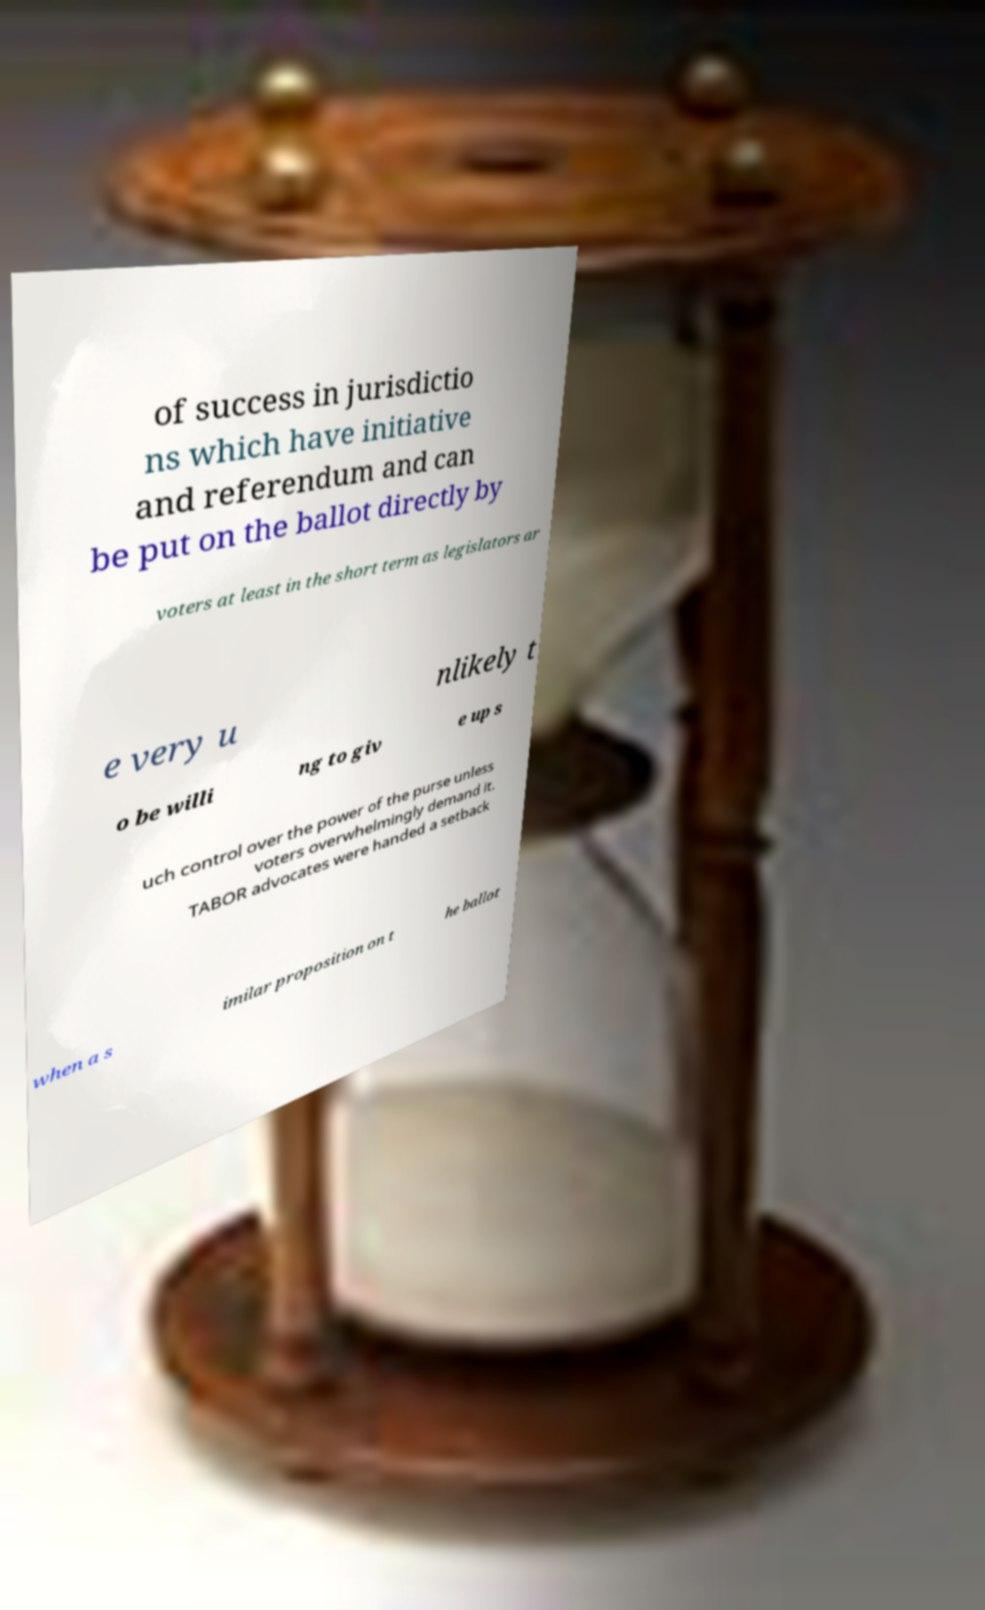Could you extract and type out the text from this image? of success in jurisdictio ns which have initiative and referendum and can be put on the ballot directly by voters at least in the short term as legislators ar e very u nlikely t o be willi ng to giv e up s uch control over the power of the purse unless voters overwhelmingly demand it. TABOR advocates were handed a setback when a s imilar proposition on t he ballot 